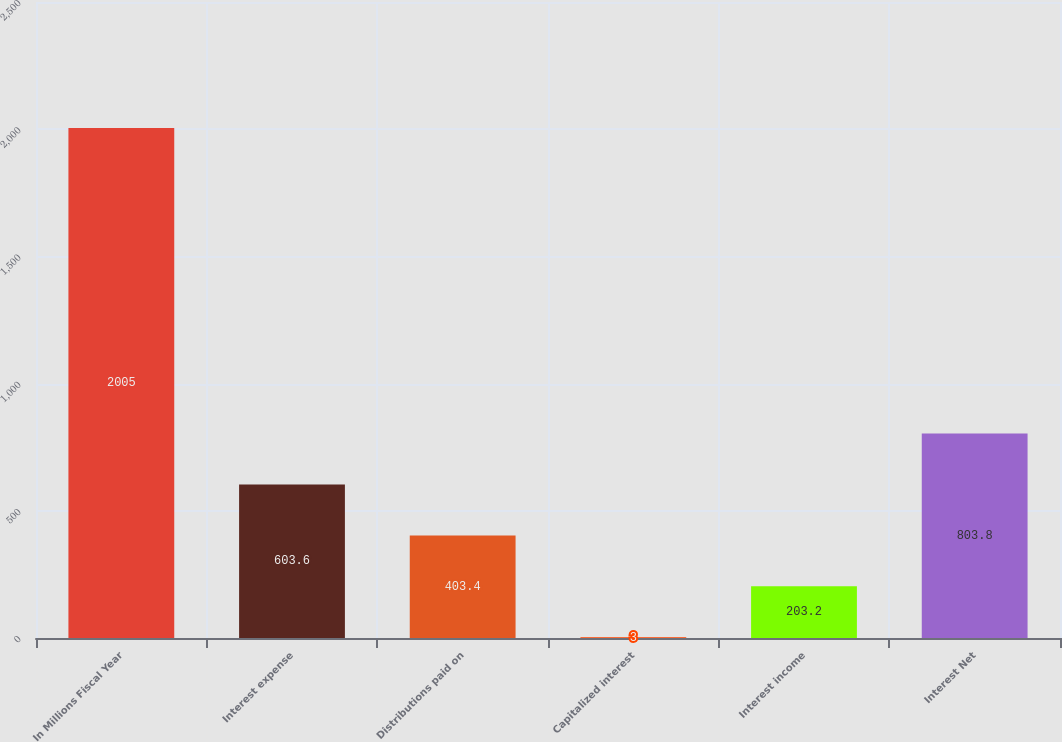Convert chart to OTSL. <chart><loc_0><loc_0><loc_500><loc_500><bar_chart><fcel>In Millions Fiscal Year<fcel>Interest expense<fcel>Distributions paid on<fcel>Capitalized interest<fcel>Interest income<fcel>Interest Net<nl><fcel>2005<fcel>603.6<fcel>403.4<fcel>3<fcel>203.2<fcel>803.8<nl></chart> 